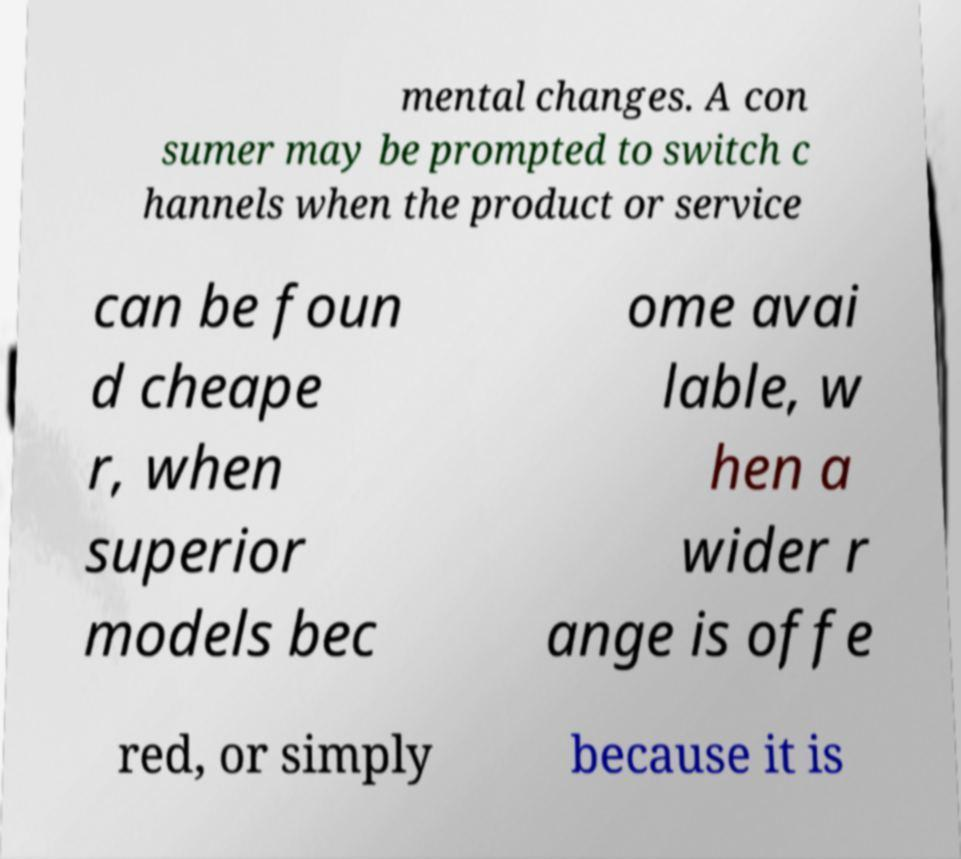Please read and relay the text visible in this image. What does it say? mental changes. A con sumer may be prompted to switch c hannels when the product or service can be foun d cheape r, when superior models bec ome avai lable, w hen a wider r ange is offe red, or simply because it is 